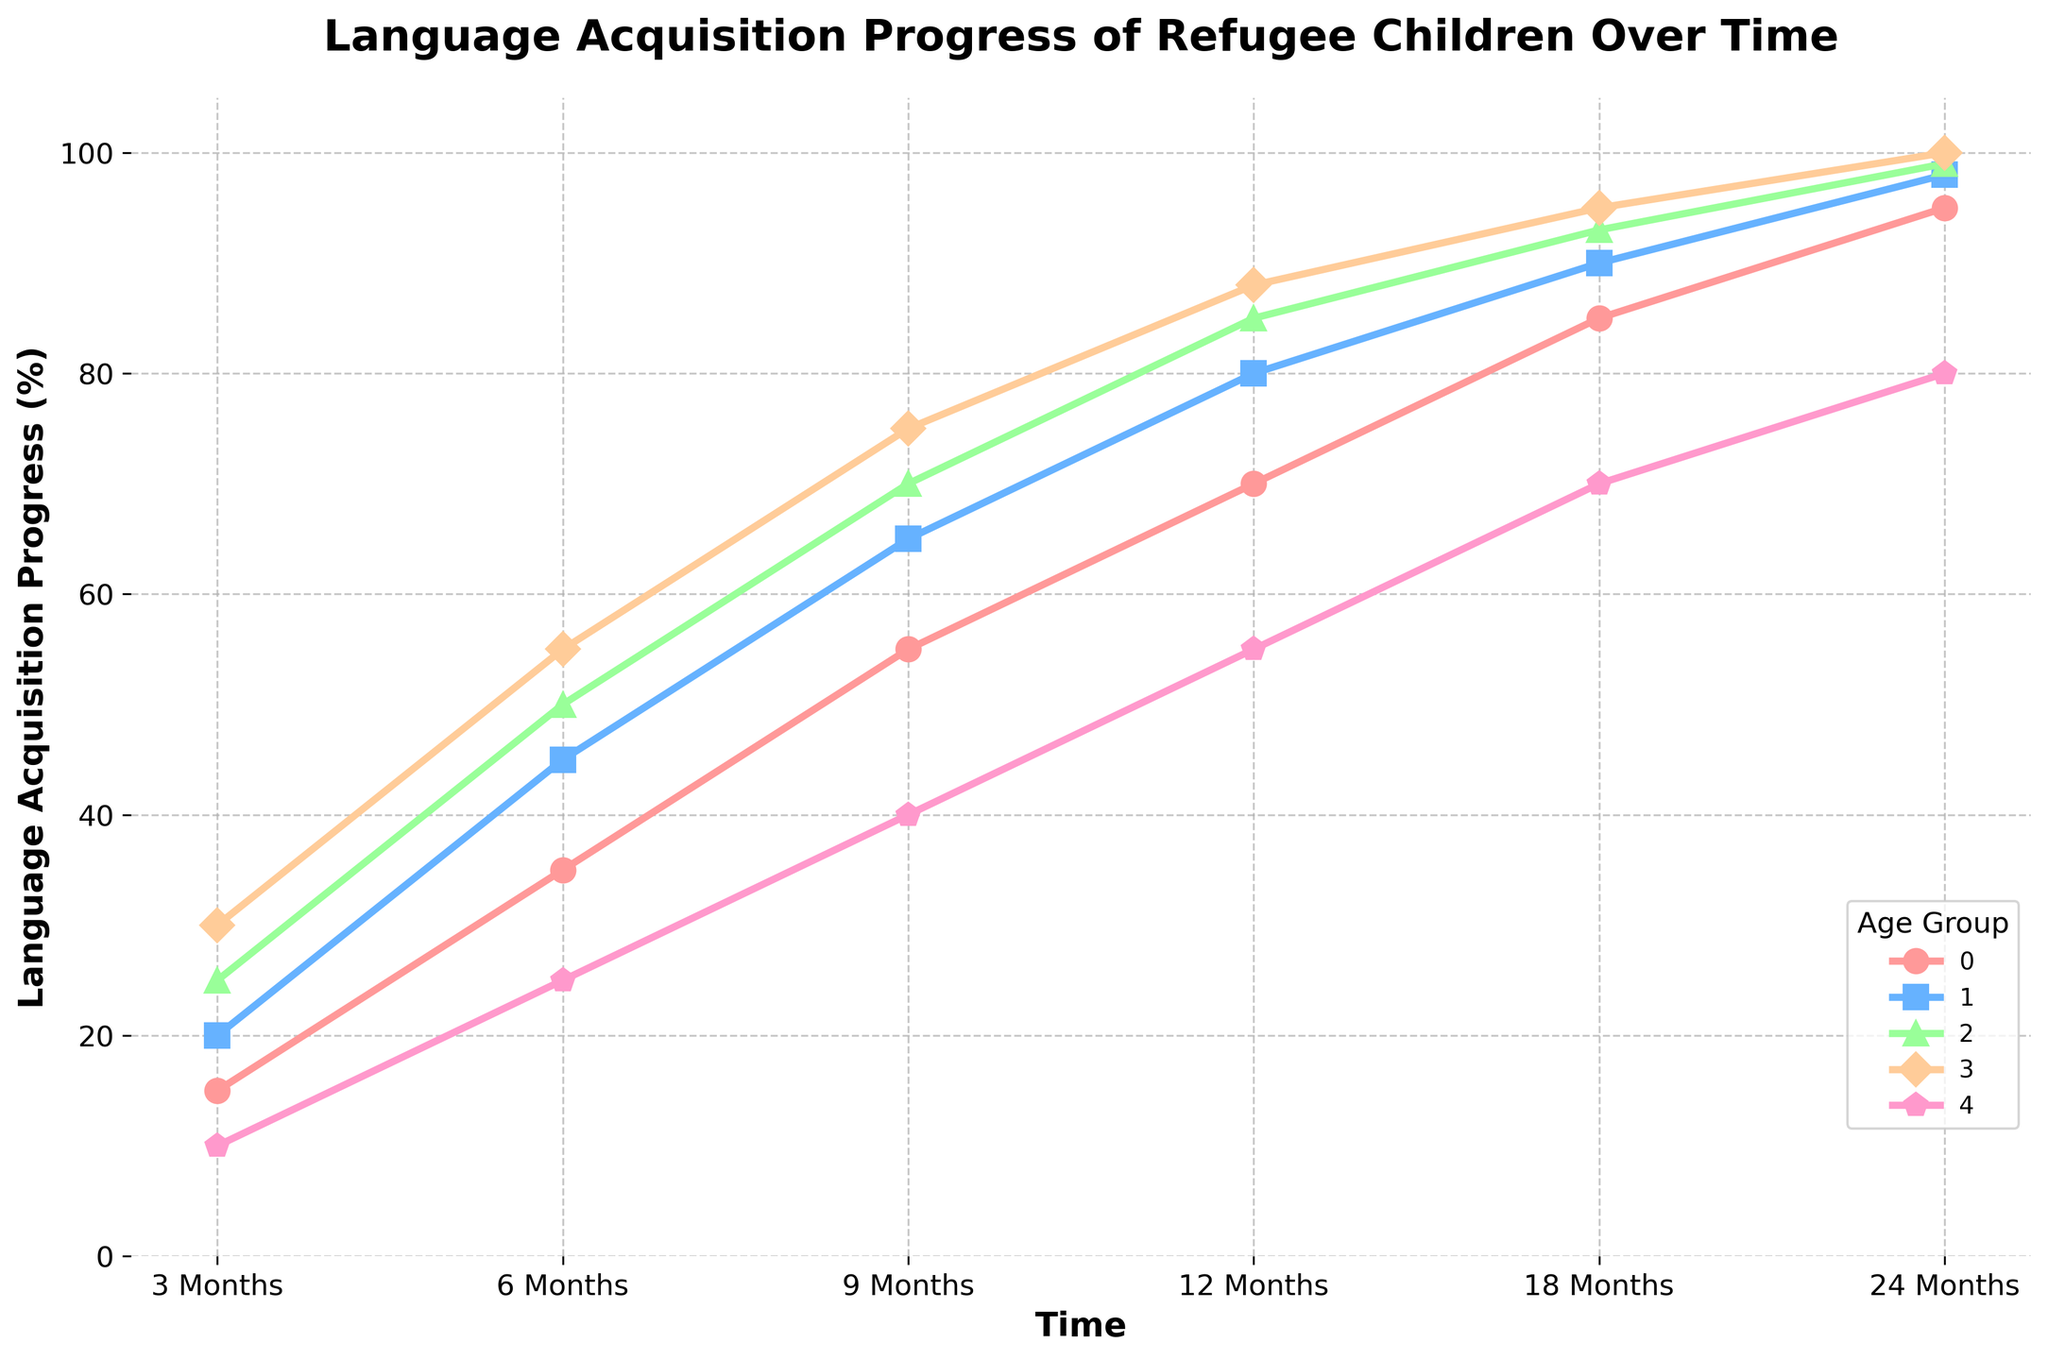What is the language acquisition progress of children aged 0-5 years at 12 months? Look at the line corresponding to the age group "0-5 years" and locate the point at 12 months.
Answer: 70% Which age group shows the fastest progress in language acquisition between 3 months and 6 months? To find the fastest progress, compare the differences in percentages between 3 and 6 months for all age groups. "16-18 years" has the highest increase of 25% (55-30).
Answer: 16-18 years What is the average language progress for the age group 11-15 years? Sum the progress values for the age group 11-15 years and divide by the number of observations: (25 + 50 + 70 + 85 + 93 + 99) / 6.
Answer: 70.33% How much more progress do children aged 6-10 years show at 6 months compared to adults (19+)? Subtract the progress percentage of adults at 6 months from that of children aged 6-10 years: 45 - 25.
Answer: 20% Between the 9-month and 18-month marks, which age group shows the least increase in language acquisition progress? Calculate the increases for each age group between 9 and 18 months: (85-55), (90-65), (93-70), (95-75), (70-40). The smallest increase is for the adults (19+), 30%.
Answer: Adults (19+) Which age group has the highest percentage of language acquisition progress at 24 months? Observe the endpoints of each line (24 months) and compare the values, the highest endpoint is for "16-18 years" at 100%.
Answer: 16-18 years Which age group shows the biggest jump between 6 months and 9 months? Calculate the increase for each age group: (55-35), (65-45), (70-50), (75-55), (40-25). The biggest jump is for "Adults (19+)" with 15%.
Answer: Adults (19+) What is the difference in progress between children aged 0-5 years and 16-18 years at 18 months? Locate the progress values at 18 months for both age groups and subtract: 95 - 85.
Answer: 10% What visual attribute differentiates the age groups on the plot? Different colors and markers are used for each age group, making them distinguishable.
Answer: Colors and markers 